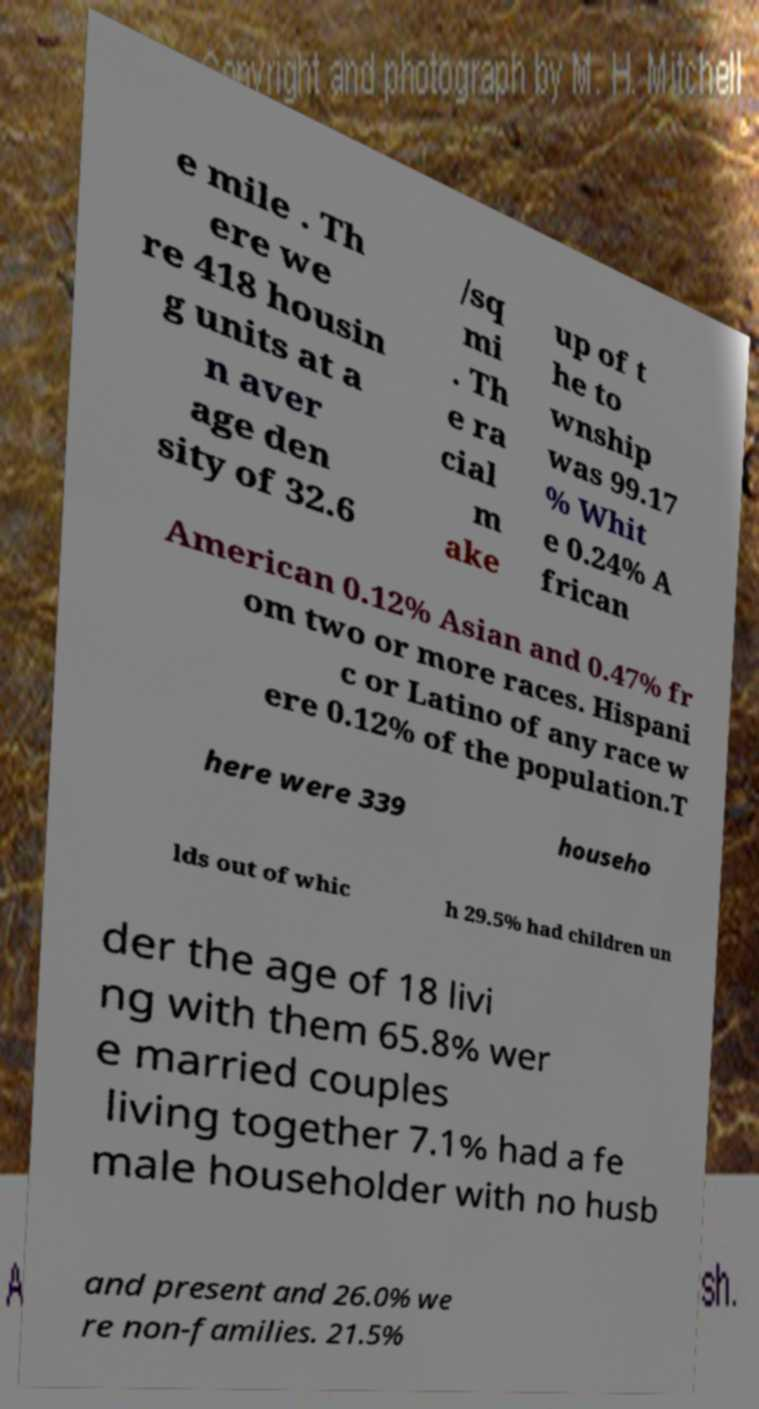Can you accurately transcribe the text from the provided image for me? e mile . Th ere we re 418 housin g units at a n aver age den sity of 32.6 /sq mi . Th e ra cial m ake up of t he to wnship was 99.17 % Whit e 0.24% A frican American 0.12% Asian and 0.47% fr om two or more races. Hispani c or Latino of any race w ere 0.12% of the population.T here were 339 househo lds out of whic h 29.5% had children un der the age of 18 livi ng with them 65.8% wer e married couples living together 7.1% had a fe male householder with no husb and present and 26.0% we re non-families. 21.5% 